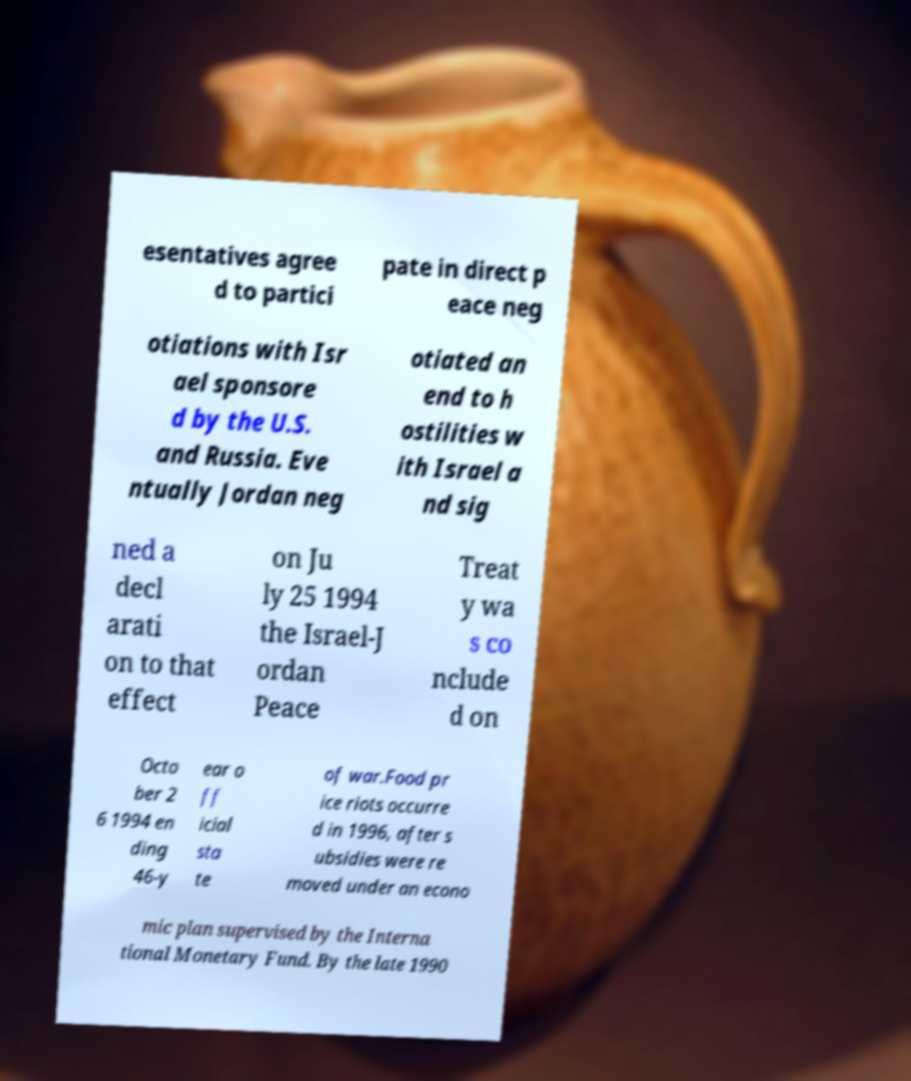I need the written content from this picture converted into text. Can you do that? esentatives agree d to partici pate in direct p eace neg otiations with Isr ael sponsore d by the U.S. and Russia. Eve ntually Jordan neg otiated an end to h ostilities w ith Israel a nd sig ned a decl arati on to that effect on Ju ly 25 1994 the Israel-J ordan Peace Treat y wa s co nclude d on Octo ber 2 6 1994 en ding 46-y ear o ff icial sta te of war.Food pr ice riots occurre d in 1996, after s ubsidies were re moved under an econo mic plan supervised by the Interna tional Monetary Fund. By the late 1990 